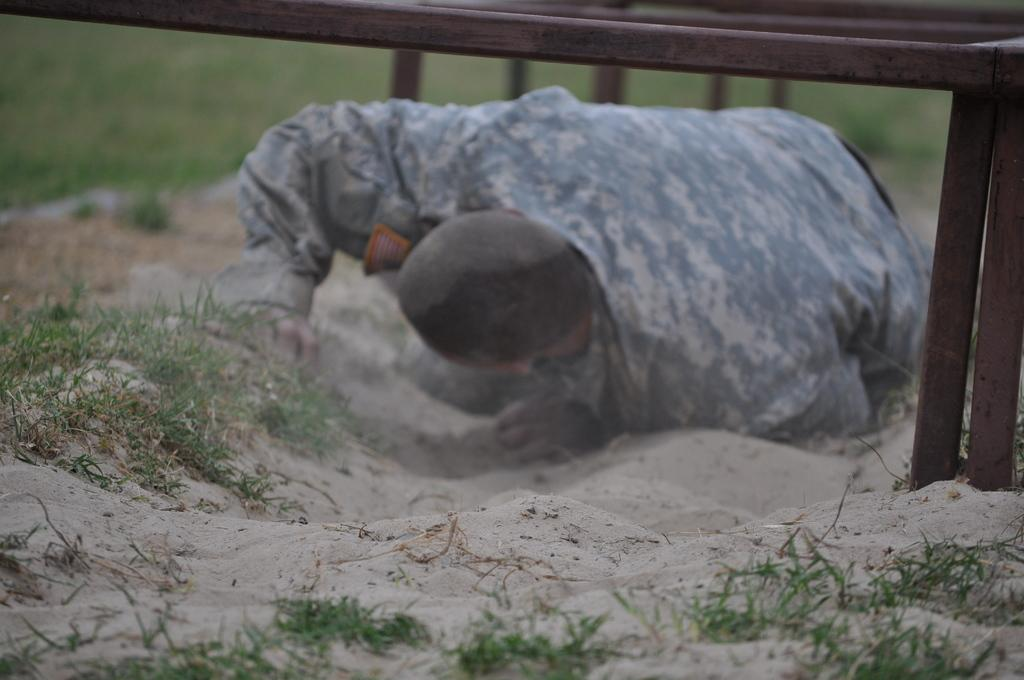What is the main subject of the image? There is an army man in the image. What is the position of the army man in the image? The army man is lying on the ground. What other object can be seen in the image? There is an iron stand in the image. What type of natural environment is visible in the image? Grass is visible in the image. What type of weather can be seen in the image? There is no indication of weather in the image, as it only shows an army man lying on the ground, an iron stand, and grass. What leaf is being used for teaching in the image? There is no leaf or teaching activity present in the image. 